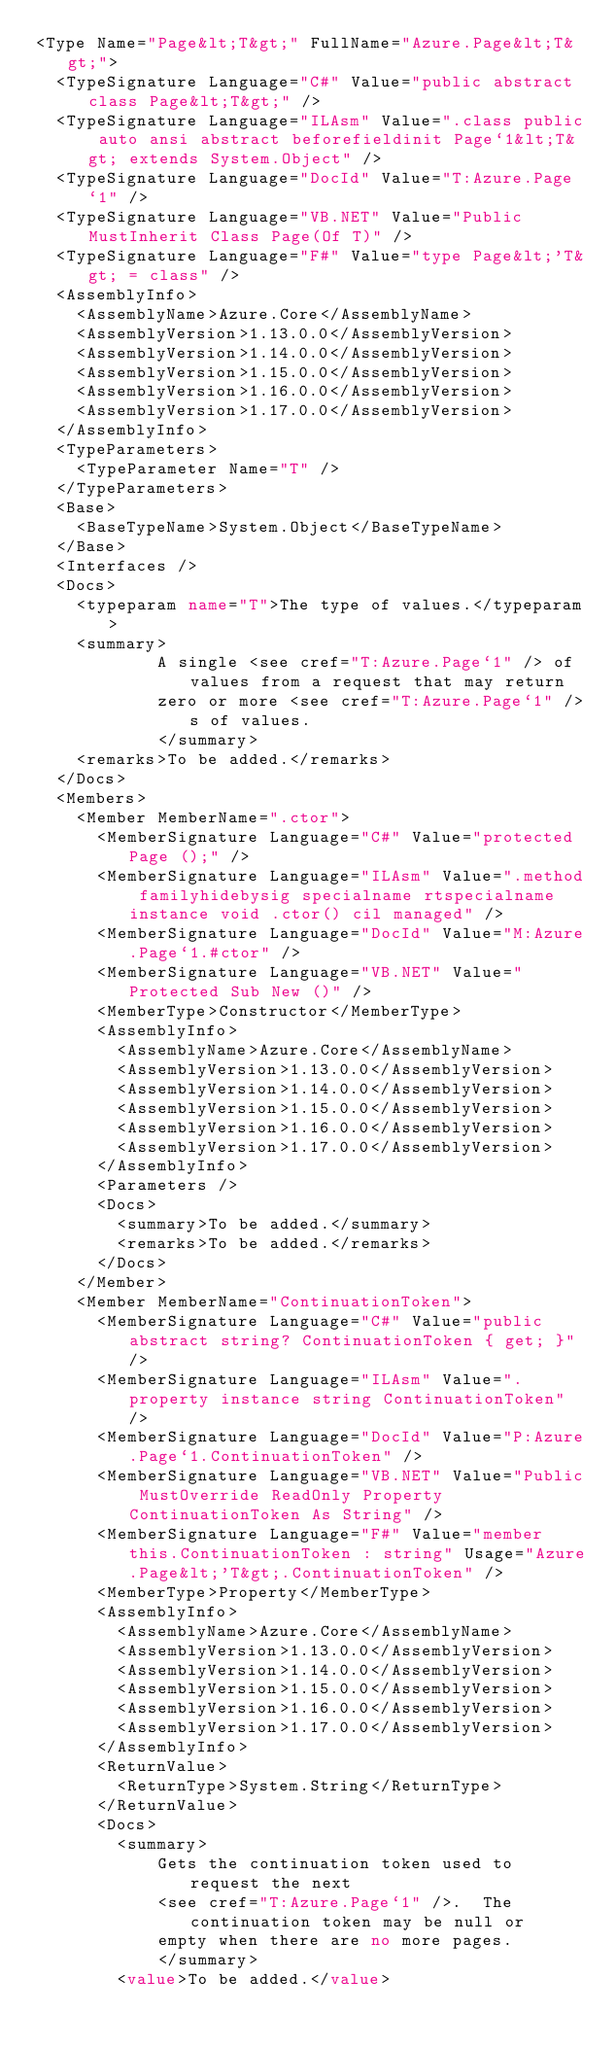Convert code to text. <code><loc_0><loc_0><loc_500><loc_500><_XML_><Type Name="Page&lt;T&gt;" FullName="Azure.Page&lt;T&gt;">
  <TypeSignature Language="C#" Value="public abstract class Page&lt;T&gt;" />
  <TypeSignature Language="ILAsm" Value=".class public auto ansi abstract beforefieldinit Page`1&lt;T&gt; extends System.Object" />
  <TypeSignature Language="DocId" Value="T:Azure.Page`1" />
  <TypeSignature Language="VB.NET" Value="Public MustInherit Class Page(Of T)" />
  <TypeSignature Language="F#" Value="type Page&lt;'T&gt; = class" />
  <AssemblyInfo>
    <AssemblyName>Azure.Core</AssemblyName>
    <AssemblyVersion>1.13.0.0</AssemblyVersion>
    <AssemblyVersion>1.14.0.0</AssemblyVersion>
    <AssemblyVersion>1.15.0.0</AssemblyVersion>
    <AssemblyVersion>1.16.0.0</AssemblyVersion>
    <AssemblyVersion>1.17.0.0</AssemblyVersion>
  </AssemblyInfo>
  <TypeParameters>
    <TypeParameter Name="T" />
  </TypeParameters>
  <Base>
    <BaseTypeName>System.Object</BaseTypeName>
  </Base>
  <Interfaces />
  <Docs>
    <typeparam name="T">The type of values.</typeparam>
    <summary>
            A single <see cref="T:Azure.Page`1" /> of values from a request that may return
            zero or more <see cref="T:Azure.Page`1" />s of values.
            </summary>
    <remarks>To be added.</remarks>
  </Docs>
  <Members>
    <Member MemberName=".ctor">
      <MemberSignature Language="C#" Value="protected Page ();" />
      <MemberSignature Language="ILAsm" Value=".method familyhidebysig specialname rtspecialname instance void .ctor() cil managed" />
      <MemberSignature Language="DocId" Value="M:Azure.Page`1.#ctor" />
      <MemberSignature Language="VB.NET" Value="Protected Sub New ()" />
      <MemberType>Constructor</MemberType>
      <AssemblyInfo>
        <AssemblyName>Azure.Core</AssemblyName>
        <AssemblyVersion>1.13.0.0</AssemblyVersion>
        <AssemblyVersion>1.14.0.0</AssemblyVersion>
        <AssemblyVersion>1.15.0.0</AssemblyVersion>
        <AssemblyVersion>1.16.0.0</AssemblyVersion>
        <AssemblyVersion>1.17.0.0</AssemblyVersion>
      </AssemblyInfo>
      <Parameters />
      <Docs>
        <summary>To be added.</summary>
        <remarks>To be added.</remarks>
      </Docs>
    </Member>
    <Member MemberName="ContinuationToken">
      <MemberSignature Language="C#" Value="public abstract string? ContinuationToken { get; }" />
      <MemberSignature Language="ILAsm" Value=".property instance string ContinuationToken" />
      <MemberSignature Language="DocId" Value="P:Azure.Page`1.ContinuationToken" />
      <MemberSignature Language="VB.NET" Value="Public MustOverride ReadOnly Property ContinuationToken As String" />
      <MemberSignature Language="F#" Value="member this.ContinuationToken : string" Usage="Azure.Page&lt;'T&gt;.ContinuationToken" />
      <MemberType>Property</MemberType>
      <AssemblyInfo>
        <AssemblyName>Azure.Core</AssemblyName>
        <AssemblyVersion>1.13.0.0</AssemblyVersion>
        <AssemblyVersion>1.14.0.0</AssemblyVersion>
        <AssemblyVersion>1.15.0.0</AssemblyVersion>
        <AssemblyVersion>1.16.0.0</AssemblyVersion>
        <AssemblyVersion>1.17.0.0</AssemblyVersion>
      </AssemblyInfo>
      <ReturnValue>
        <ReturnType>System.String</ReturnType>
      </ReturnValue>
      <Docs>
        <summary>
            Gets the continuation token used to request the next
            <see cref="T:Azure.Page`1" />.  The continuation token may be null or
            empty when there are no more pages.
            </summary>
        <value>To be added.</value></code> 